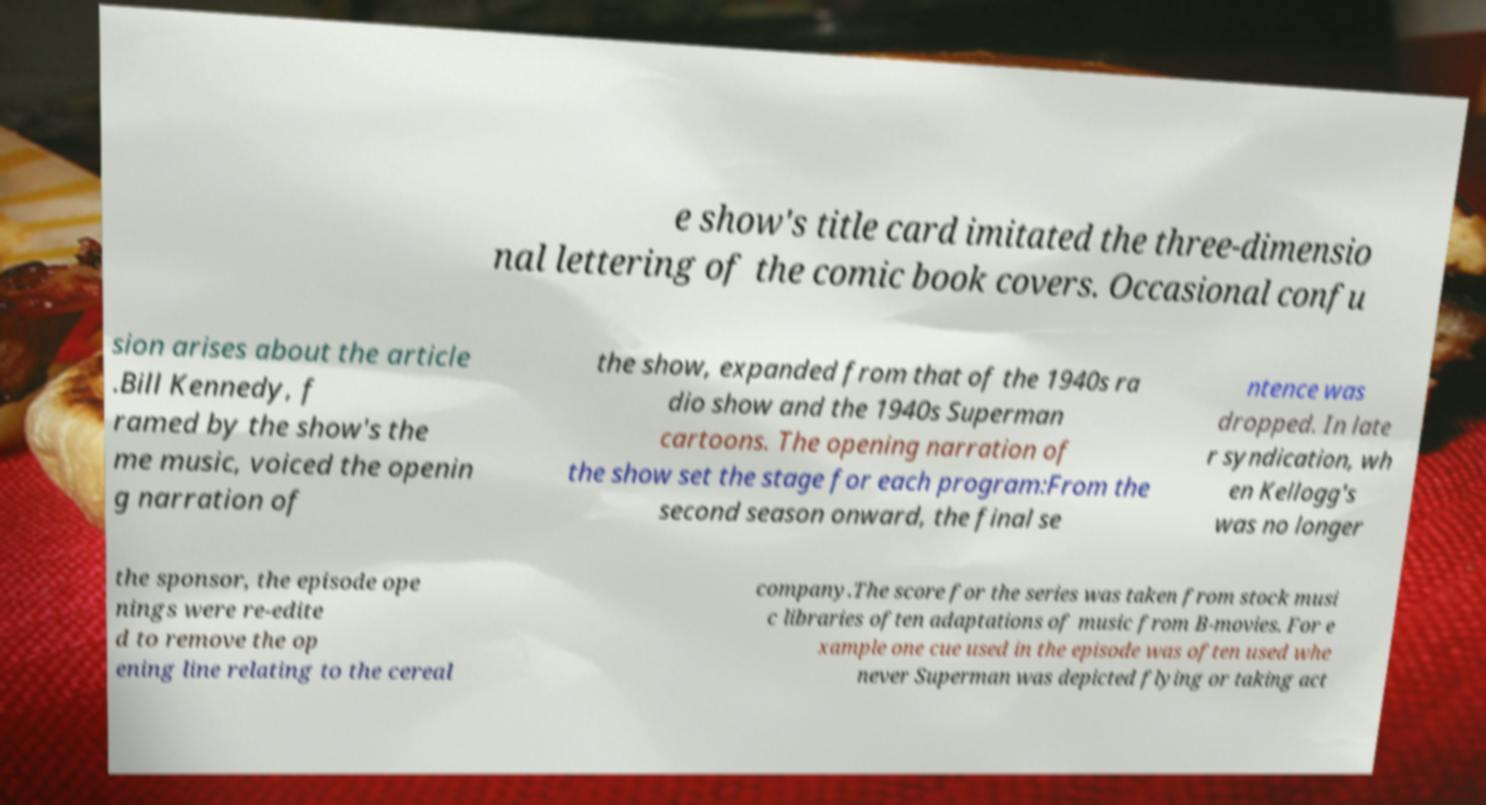Could you extract and type out the text from this image? e show's title card imitated the three-dimensio nal lettering of the comic book covers. Occasional confu sion arises about the article .Bill Kennedy, f ramed by the show's the me music, voiced the openin g narration of the show, expanded from that of the 1940s ra dio show and the 1940s Superman cartoons. The opening narration of the show set the stage for each program:From the second season onward, the final se ntence was dropped. In late r syndication, wh en Kellogg's was no longer the sponsor, the episode ope nings were re-edite d to remove the op ening line relating to the cereal company.The score for the series was taken from stock musi c libraries often adaptations of music from B-movies. For e xample one cue used in the episode was often used whe never Superman was depicted flying or taking act 